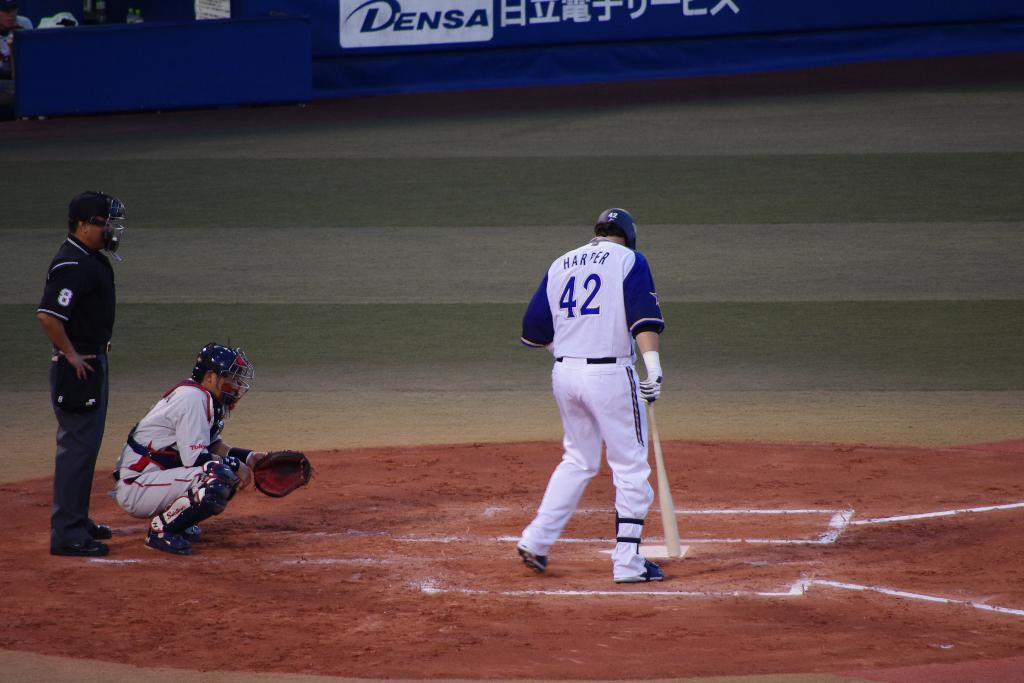<image>
Render a clear and concise summary of the photo. Batter wearing the number 42 looking down at the ground. 